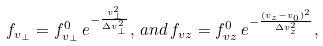<formula> <loc_0><loc_0><loc_500><loc_500>f _ { v _ { \perp } } = f _ { v _ { \perp } } ^ { 0 } \, e ^ { - \frac { v _ { \perp } ^ { 2 } } { \Delta v _ { \perp } ^ { 2 } } } , \, a n d \, f _ { v z } = f _ { v z } ^ { 0 } \, e ^ { - \frac { ( v _ { z } - v _ { 0 } ) ^ { 2 } } { \Delta v _ { z } ^ { 2 } } } ,</formula> 